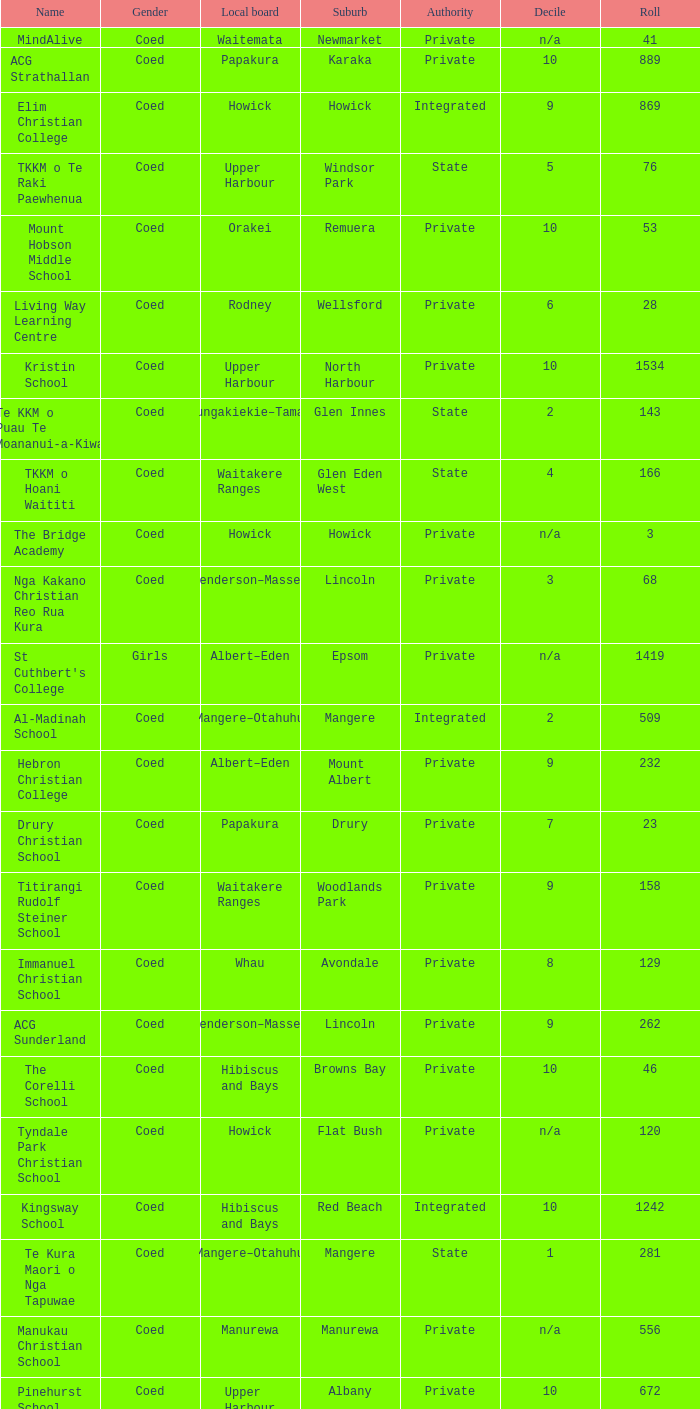What is the name when the local board is albert–eden, and a Decile of 9? Hebron Christian College. 